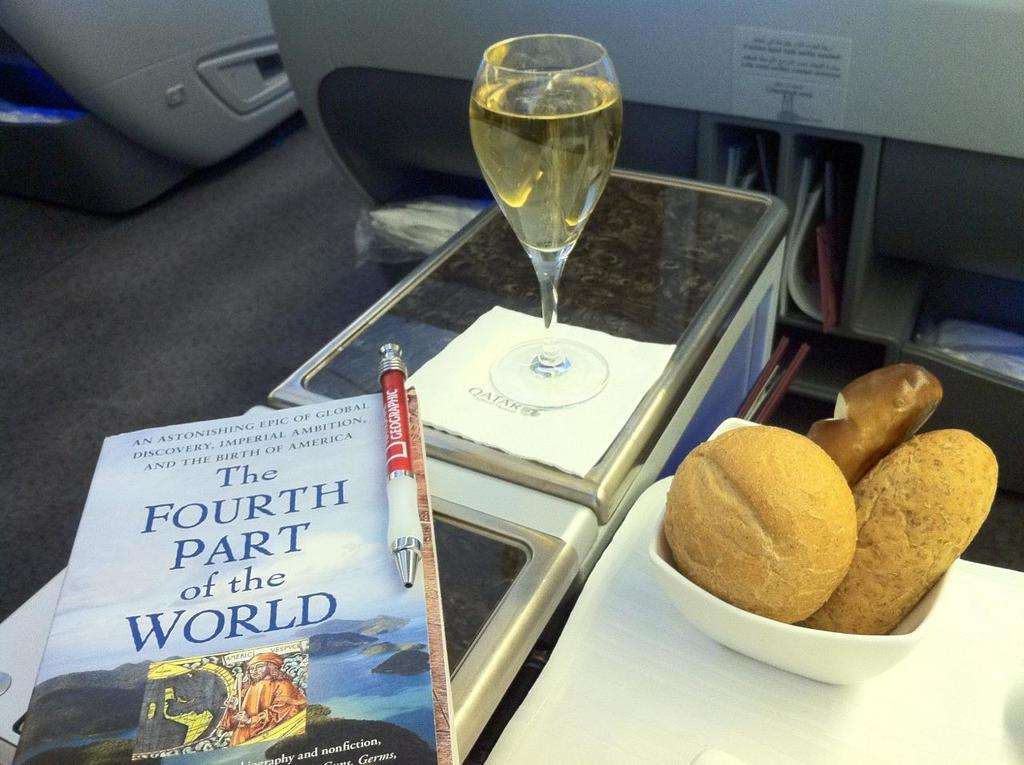Provide a one-sentence caption for the provided image. Most likely on a plane a person took a photo of there bread basket, wine and book; the book is the fourth part of the world. 